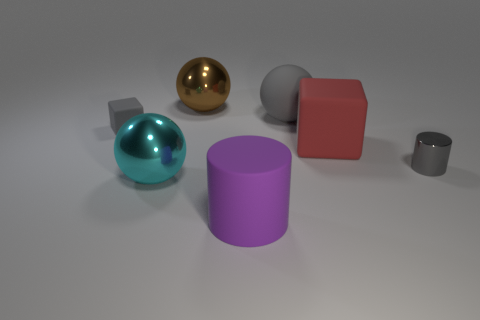Are there any other things that have the same material as the brown thing?
Offer a very short reply. Yes. What number of matte objects are in front of the tiny gray shiny cylinder and on the left side of the large cylinder?
Your answer should be compact. 0. Is the number of cyan objects that are behind the red block less than the number of gray balls on the left side of the big rubber cylinder?
Your answer should be compact. No. Does the big cyan metal object have the same shape as the red rubber object?
Your response must be concise. No. How many other things are there of the same size as the gray cube?
Ensure brevity in your answer.  1. What number of objects are either large things behind the small block or big things left of the large gray matte object?
Provide a short and direct response. 4. What number of large gray matte objects have the same shape as the cyan metallic object?
Your answer should be compact. 1. What is the gray object that is right of the brown object and left of the big cube made of?
Your response must be concise. Rubber. What number of large cyan shiny things are on the right side of the red cube?
Keep it short and to the point. 0. What number of balls are there?
Your answer should be compact. 3. 